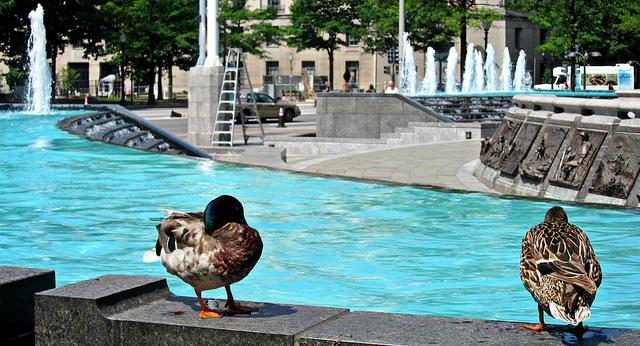Why are they here? Please explain your reasoning. like water. Ducks love to swim 